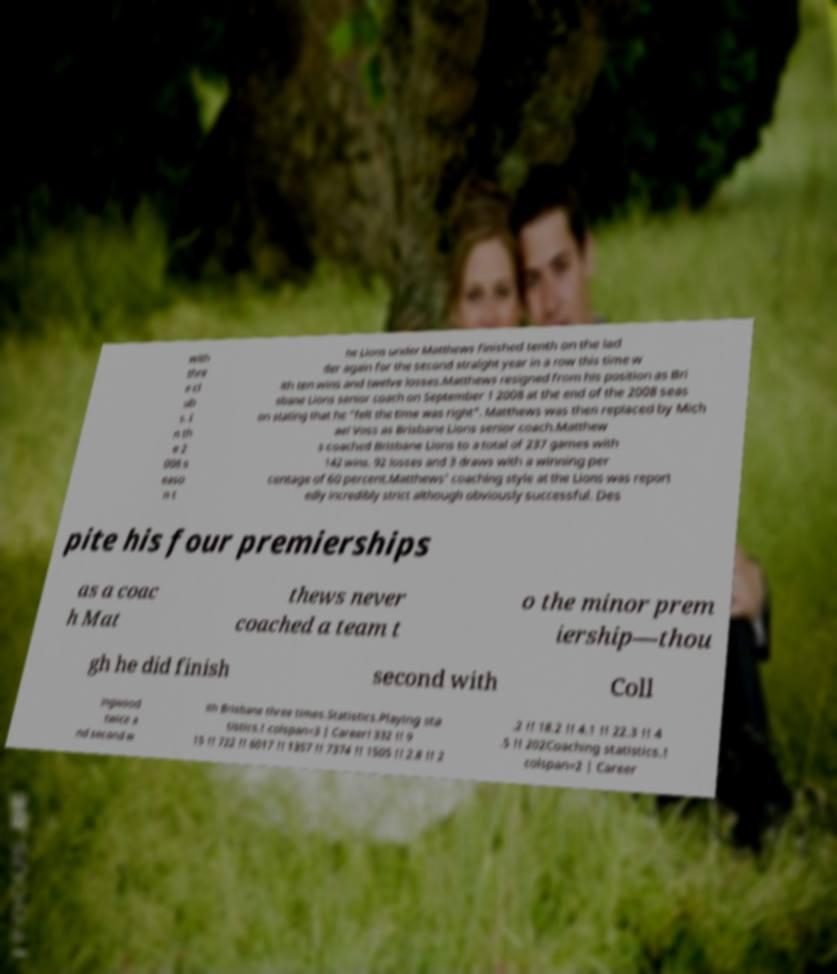Please identify and transcribe the text found in this image. with thre e cl ub s. I n th e 2 008 s easo n t he Lions under Matthews finished tenth on the lad der again for the second straight year in a row this time w ith ten wins and twelve losses.Matthews resigned from his position as Bri sbane Lions senior coach on September 1 2008 at the end of the 2008 seas on stating that he "felt the time was right". Matthews was then replaced by Mich ael Voss as Brisbane Lions senior coach.Matthew s coached Brisbane Lions to a total of 237 games with 142 wins, 92 losses and 3 draws with a winning per centage of 60 percent.Matthews' coaching style at the Lions was report edly incredibly strict although obviously successful. Des pite his four premierships as a coac h Mat thews never coached a team t o the minor prem iership—thou gh he did finish second with Coll ingwood twice a nd second w ith Brisbane three times.Statistics.Playing sta tistics.! colspan=3 | Career! 332 !! 9 15 !! 722 !! 6017 !! 1357 !! 7374 !! 1505 !! 2.8 !! 2 .2 !! 18.2 !! 4.1 !! 22.3 !! 4 .5 !! 202Coaching statistics.! colspan=2 | Career 